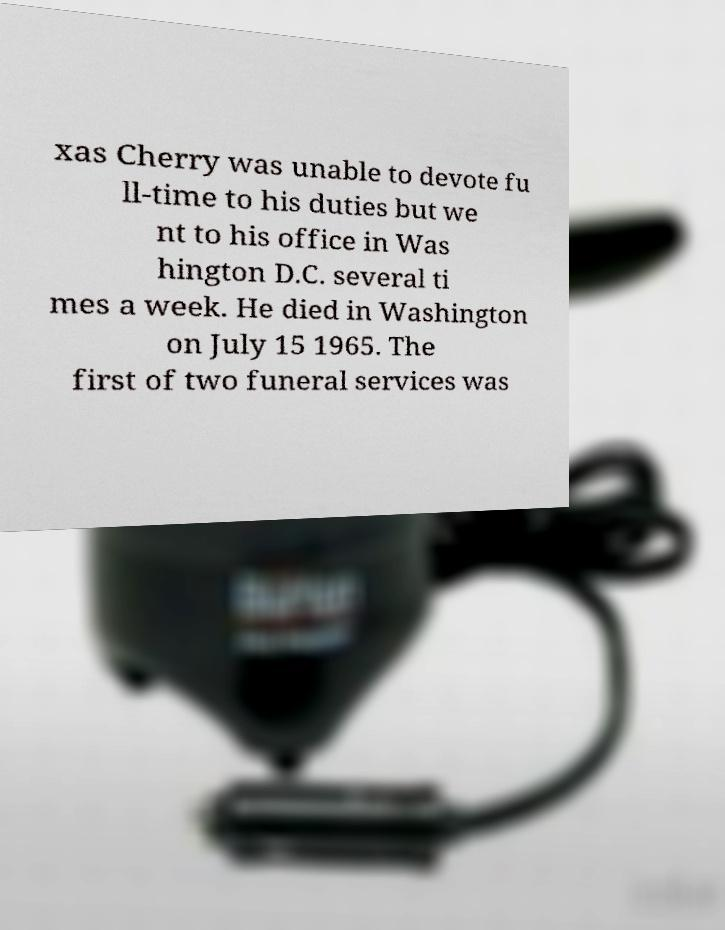Please identify and transcribe the text found in this image. xas Cherry was unable to devote fu ll-time to his duties but we nt to his office in Was hington D.C. several ti mes a week. He died in Washington on July 15 1965. The first of two funeral services was 